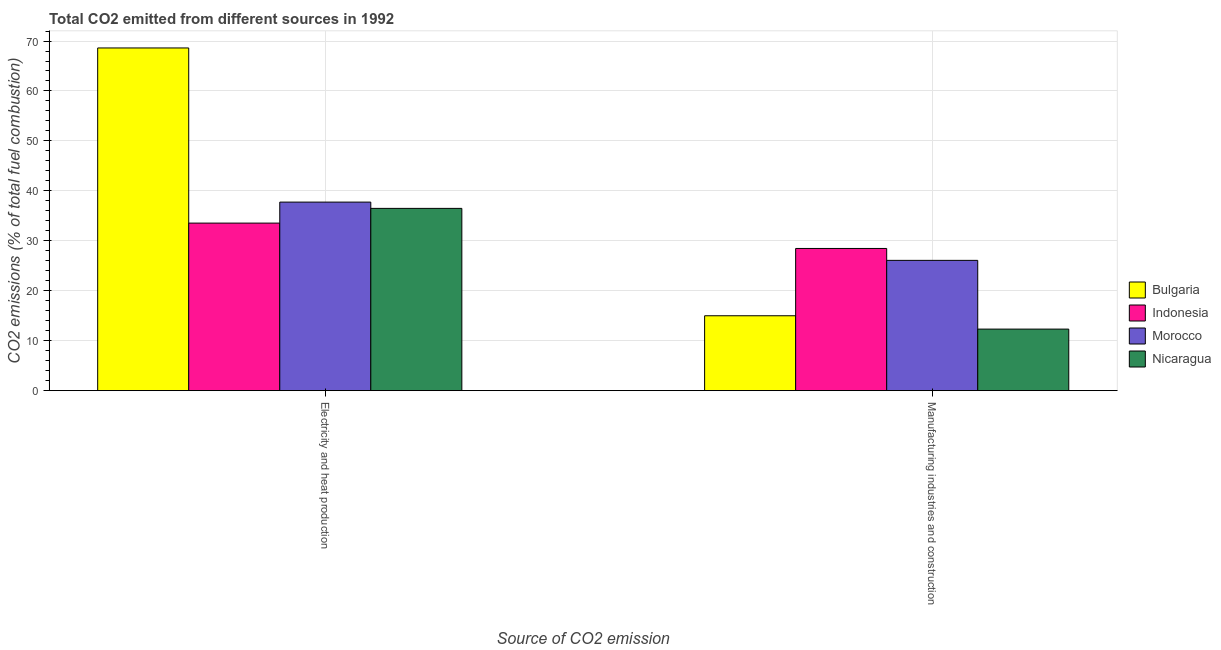How many different coloured bars are there?
Ensure brevity in your answer.  4. How many groups of bars are there?
Ensure brevity in your answer.  2. Are the number of bars per tick equal to the number of legend labels?
Keep it short and to the point. Yes. How many bars are there on the 2nd tick from the right?
Keep it short and to the point. 4. What is the label of the 2nd group of bars from the left?
Provide a succinct answer. Manufacturing industries and construction. What is the co2 emissions due to electricity and heat production in Nicaragua?
Offer a very short reply. 36.49. Across all countries, what is the maximum co2 emissions due to electricity and heat production?
Make the answer very short. 68.61. Across all countries, what is the minimum co2 emissions due to electricity and heat production?
Make the answer very short. 33.55. In which country was the co2 emissions due to manufacturing industries maximum?
Give a very brief answer. Indonesia. In which country was the co2 emissions due to manufacturing industries minimum?
Offer a terse response. Nicaragua. What is the total co2 emissions due to electricity and heat production in the graph?
Give a very brief answer. 176.4. What is the difference between the co2 emissions due to electricity and heat production in Nicaragua and that in Indonesia?
Ensure brevity in your answer.  2.95. What is the difference between the co2 emissions due to electricity and heat production in Indonesia and the co2 emissions due to manufacturing industries in Morocco?
Provide a succinct answer. 7.46. What is the average co2 emissions due to manufacturing industries per country?
Give a very brief answer. 20.47. What is the difference between the co2 emissions due to electricity and heat production and co2 emissions due to manufacturing industries in Indonesia?
Offer a very short reply. 5.08. In how many countries, is the co2 emissions due to electricity and heat production greater than 44 %?
Offer a very short reply. 1. What is the ratio of the co2 emissions due to electricity and heat production in Morocco to that in Indonesia?
Provide a succinct answer. 1.13. Is the co2 emissions due to electricity and heat production in Morocco less than that in Indonesia?
Provide a succinct answer. No. What does the 4th bar from the left in Electricity and heat production represents?
Your answer should be compact. Nicaragua. How many countries are there in the graph?
Provide a short and direct response. 4. Does the graph contain any zero values?
Give a very brief answer. No. Does the graph contain grids?
Provide a succinct answer. Yes. How many legend labels are there?
Keep it short and to the point. 4. What is the title of the graph?
Give a very brief answer. Total CO2 emitted from different sources in 1992. What is the label or title of the X-axis?
Keep it short and to the point. Source of CO2 emission. What is the label or title of the Y-axis?
Give a very brief answer. CO2 emissions (% of total fuel combustion). What is the CO2 emissions (% of total fuel combustion) of Bulgaria in Electricity and heat production?
Your response must be concise. 68.61. What is the CO2 emissions (% of total fuel combustion) of Indonesia in Electricity and heat production?
Your answer should be very brief. 33.55. What is the CO2 emissions (% of total fuel combustion) in Morocco in Electricity and heat production?
Provide a short and direct response. 37.75. What is the CO2 emissions (% of total fuel combustion) in Nicaragua in Electricity and heat production?
Provide a succinct answer. 36.49. What is the CO2 emissions (% of total fuel combustion) of Bulgaria in Manufacturing industries and construction?
Provide a succinct answer. 14.99. What is the CO2 emissions (% of total fuel combustion) in Indonesia in Manufacturing industries and construction?
Your response must be concise. 28.47. What is the CO2 emissions (% of total fuel combustion) in Morocco in Manufacturing industries and construction?
Give a very brief answer. 26.08. What is the CO2 emissions (% of total fuel combustion) of Nicaragua in Manufacturing industries and construction?
Provide a short and direct response. 12.32. Across all Source of CO2 emission, what is the maximum CO2 emissions (% of total fuel combustion) of Bulgaria?
Your answer should be compact. 68.61. Across all Source of CO2 emission, what is the maximum CO2 emissions (% of total fuel combustion) of Indonesia?
Make the answer very short. 33.55. Across all Source of CO2 emission, what is the maximum CO2 emissions (% of total fuel combustion) in Morocco?
Offer a terse response. 37.75. Across all Source of CO2 emission, what is the maximum CO2 emissions (% of total fuel combustion) in Nicaragua?
Make the answer very short. 36.49. Across all Source of CO2 emission, what is the minimum CO2 emissions (% of total fuel combustion) of Bulgaria?
Provide a succinct answer. 14.99. Across all Source of CO2 emission, what is the minimum CO2 emissions (% of total fuel combustion) of Indonesia?
Provide a succinct answer. 28.47. Across all Source of CO2 emission, what is the minimum CO2 emissions (% of total fuel combustion) of Morocco?
Make the answer very short. 26.08. Across all Source of CO2 emission, what is the minimum CO2 emissions (% of total fuel combustion) in Nicaragua?
Keep it short and to the point. 12.32. What is the total CO2 emissions (% of total fuel combustion) in Bulgaria in the graph?
Provide a succinct answer. 83.6. What is the total CO2 emissions (% of total fuel combustion) of Indonesia in the graph?
Offer a terse response. 62.01. What is the total CO2 emissions (% of total fuel combustion) of Morocco in the graph?
Keep it short and to the point. 63.83. What is the total CO2 emissions (% of total fuel combustion) of Nicaragua in the graph?
Offer a terse response. 48.82. What is the difference between the CO2 emissions (% of total fuel combustion) in Bulgaria in Electricity and heat production and that in Manufacturing industries and construction?
Ensure brevity in your answer.  53.62. What is the difference between the CO2 emissions (% of total fuel combustion) of Indonesia in Electricity and heat production and that in Manufacturing industries and construction?
Provide a succinct answer. 5.08. What is the difference between the CO2 emissions (% of total fuel combustion) in Morocco in Electricity and heat production and that in Manufacturing industries and construction?
Provide a short and direct response. 11.66. What is the difference between the CO2 emissions (% of total fuel combustion) in Nicaragua in Electricity and heat production and that in Manufacturing industries and construction?
Give a very brief answer. 24.17. What is the difference between the CO2 emissions (% of total fuel combustion) of Bulgaria in Electricity and heat production and the CO2 emissions (% of total fuel combustion) of Indonesia in Manufacturing industries and construction?
Your answer should be very brief. 40.14. What is the difference between the CO2 emissions (% of total fuel combustion) in Bulgaria in Electricity and heat production and the CO2 emissions (% of total fuel combustion) in Morocco in Manufacturing industries and construction?
Offer a terse response. 42.53. What is the difference between the CO2 emissions (% of total fuel combustion) in Bulgaria in Electricity and heat production and the CO2 emissions (% of total fuel combustion) in Nicaragua in Manufacturing industries and construction?
Ensure brevity in your answer.  56.29. What is the difference between the CO2 emissions (% of total fuel combustion) in Indonesia in Electricity and heat production and the CO2 emissions (% of total fuel combustion) in Morocco in Manufacturing industries and construction?
Your answer should be compact. 7.46. What is the difference between the CO2 emissions (% of total fuel combustion) in Indonesia in Electricity and heat production and the CO2 emissions (% of total fuel combustion) in Nicaragua in Manufacturing industries and construction?
Provide a short and direct response. 21.22. What is the difference between the CO2 emissions (% of total fuel combustion) of Morocco in Electricity and heat production and the CO2 emissions (% of total fuel combustion) of Nicaragua in Manufacturing industries and construction?
Offer a terse response. 25.43. What is the average CO2 emissions (% of total fuel combustion) of Bulgaria per Source of CO2 emission?
Make the answer very short. 41.8. What is the average CO2 emissions (% of total fuel combustion) in Indonesia per Source of CO2 emission?
Your answer should be compact. 31.01. What is the average CO2 emissions (% of total fuel combustion) in Morocco per Source of CO2 emission?
Make the answer very short. 31.92. What is the average CO2 emissions (% of total fuel combustion) in Nicaragua per Source of CO2 emission?
Provide a short and direct response. 24.41. What is the difference between the CO2 emissions (% of total fuel combustion) in Bulgaria and CO2 emissions (% of total fuel combustion) in Indonesia in Electricity and heat production?
Your response must be concise. 35.07. What is the difference between the CO2 emissions (% of total fuel combustion) of Bulgaria and CO2 emissions (% of total fuel combustion) of Morocco in Electricity and heat production?
Offer a very short reply. 30.86. What is the difference between the CO2 emissions (% of total fuel combustion) in Bulgaria and CO2 emissions (% of total fuel combustion) in Nicaragua in Electricity and heat production?
Give a very brief answer. 32.12. What is the difference between the CO2 emissions (% of total fuel combustion) in Indonesia and CO2 emissions (% of total fuel combustion) in Morocco in Electricity and heat production?
Keep it short and to the point. -4.2. What is the difference between the CO2 emissions (% of total fuel combustion) in Indonesia and CO2 emissions (% of total fuel combustion) in Nicaragua in Electricity and heat production?
Offer a very short reply. -2.95. What is the difference between the CO2 emissions (% of total fuel combustion) in Morocco and CO2 emissions (% of total fuel combustion) in Nicaragua in Electricity and heat production?
Provide a succinct answer. 1.26. What is the difference between the CO2 emissions (% of total fuel combustion) of Bulgaria and CO2 emissions (% of total fuel combustion) of Indonesia in Manufacturing industries and construction?
Your answer should be compact. -13.48. What is the difference between the CO2 emissions (% of total fuel combustion) in Bulgaria and CO2 emissions (% of total fuel combustion) in Morocco in Manufacturing industries and construction?
Provide a short and direct response. -11.09. What is the difference between the CO2 emissions (% of total fuel combustion) in Bulgaria and CO2 emissions (% of total fuel combustion) in Nicaragua in Manufacturing industries and construction?
Keep it short and to the point. 2.67. What is the difference between the CO2 emissions (% of total fuel combustion) in Indonesia and CO2 emissions (% of total fuel combustion) in Morocco in Manufacturing industries and construction?
Offer a terse response. 2.38. What is the difference between the CO2 emissions (% of total fuel combustion) in Indonesia and CO2 emissions (% of total fuel combustion) in Nicaragua in Manufacturing industries and construction?
Give a very brief answer. 16.15. What is the difference between the CO2 emissions (% of total fuel combustion) of Morocco and CO2 emissions (% of total fuel combustion) of Nicaragua in Manufacturing industries and construction?
Keep it short and to the point. 13.76. What is the ratio of the CO2 emissions (% of total fuel combustion) in Bulgaria in Electricity and heat production to that in Manufacturing industries and construction?
Give a very brief answer. 4.58. What is the ratio of the CO2 emissions (% of total fuel combustion) in Indonesia in Electricity and heat production to that in Manufacturing industries and construction?
Keep it short and to the point. 1.18. What is the ratio of the CO2 emissions (% of total fuel combustion) of Morocco in Electricity and heat production to that in Manufacturing industries and construction?
Provide a succinct answer. 1.45. What is the ratio of the CO2 emissions (% of total fuel combustion) in Nicaragua in Electricity and heat production to that in Manufacturing industries and construction?
Offer a very short reply. 2.96. What is the difference between the highest and the second highest CO2 emissions (% of total fuel combustion) of Bulgaria?
Ensure brevity in your answer.  53.62. What is the difference between the highest and the second highest CO2 emissions (% of total fuel combustion) in Indonesia?
Offer a very short reply. 5.08. What is the difference between the highest and the second highest CO2 emissions (% of total fuel combustion) in Morocco?
Ensure brevity in your answer.  11.66. What is the difference between the highest and the second highest CO2 emissions (% of total fuel combustion) in Nicaragua?
Your answer should be compact. 24.17. What is the difference between the highest and the lowest CO2 emissions (% of total fuel combustion) in Bulgaria?
Make the answer very short. 53.62. What is the difference between the highest and the lowest CO2 emissions (% of total fuel combustion) of Indonesia?
Offer a terse response. 5.08. What is the difference between the highest and the lowest CO2 emissions (% of total fuel combustion) in Morocco?
Ensure brevity in your answer.  11.66. What is the difference between the highest and the lowest CO2 emissions (% of total fuel combustion) of Nicaragua?
Your answer should be very brief. 24.17. 